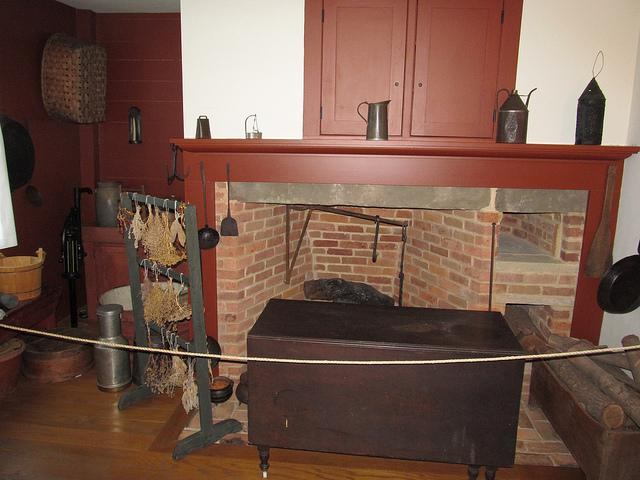Why is the area in the room roped off? display 